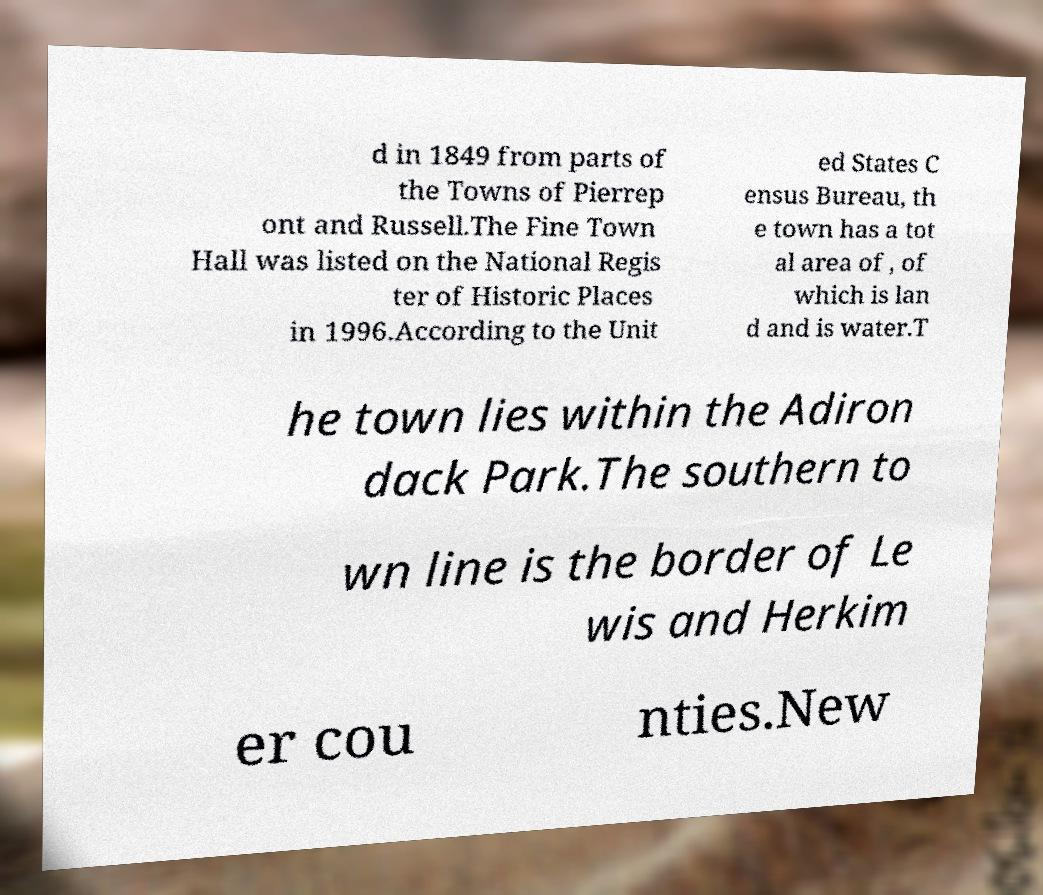Could you assist in decoding the text presented in this image and type it out clearly? d in 1849 from parts of the Towns of Pierrep ont and Russell.The Fine Town Hall was listed on the National Regis ter of Historic Places in 1996.According to the Unit ed States C ensus Bureau, th e town has a tot al area of , of which is lan d and is water.T he town lies within the Adiron dack Park.The southern to wn line is the border of Le wis and Herkim er cou nties.New 